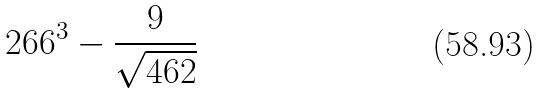Convert formula to latex. <formula><loc_0><loc_0><loc_500><loc_500>2 6 6 ^ { 3 } - \frac { 9 } { \sqrt { 4 6 2 } }</formula> 